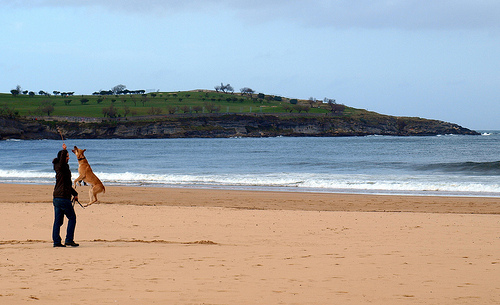What kind of kite is the person holding? The kite appears to be a dual-line stunt kite, recognizable by its triangular shape and the way it's being held. These kites allow for precise control and are often used for aerial tricks and maneuvers. 